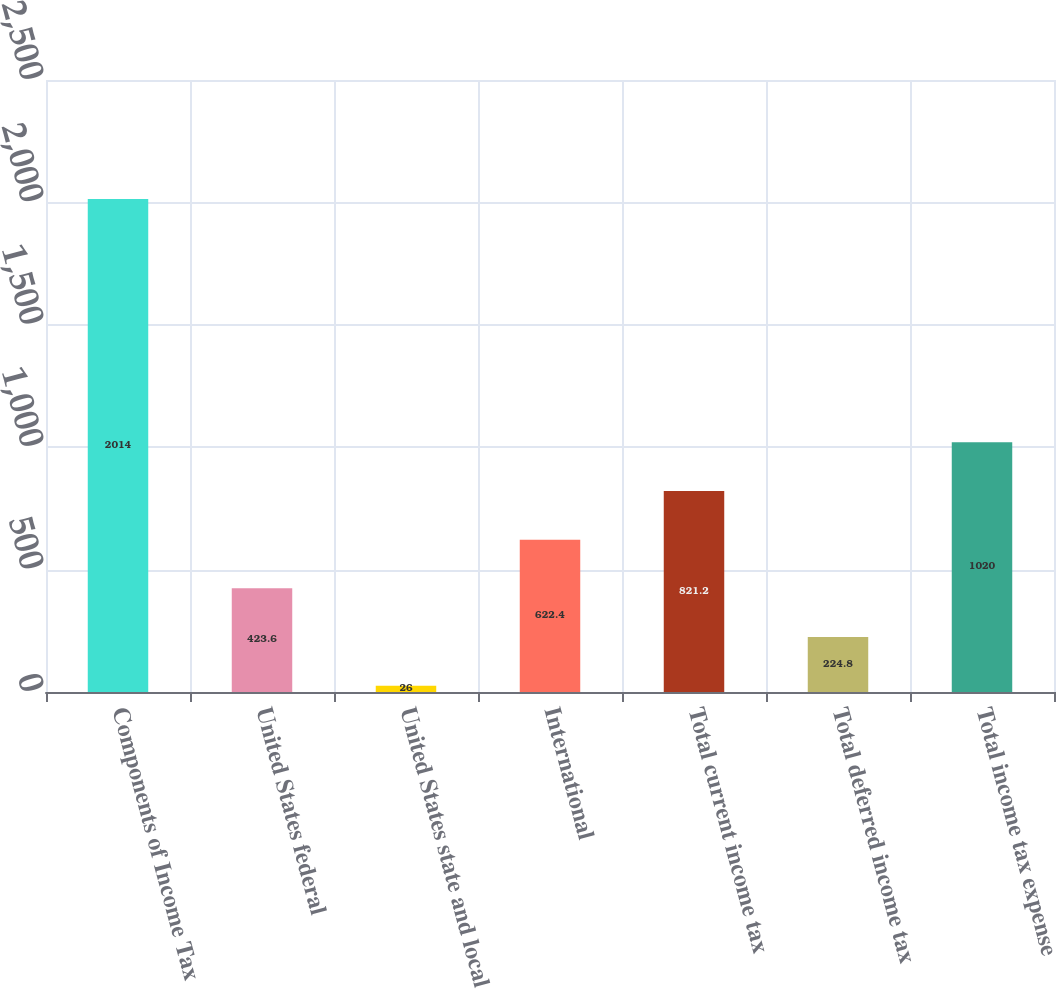Convert chart. <chart><loc_0><loc_0><loc_500><loc_500><bar_chart><fcel>Components of Income Tax<fcel>United States federal<fcel>United States state and local<fcel>International<fcel>Total current income tax<fcel>Total deferred income tax<fcel>Total income tax expense<nl><fcel>2014<fcel>423.6<fcel>26<fcel>622.4<fcel>821.2<fcel>224.8<fcel>1020<nl></chart> 